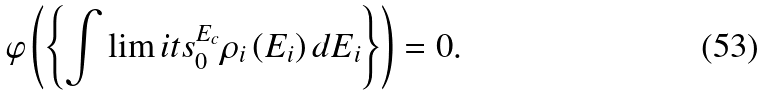Convert formula to latex. <formula><loc_0><loc_0><loc_500><loc_500>\varphi \left ( \left \{ \int \lim i t s _ { 0 } ^ { E _ { c } } \rho _ { i } \left ( E _ { i } \right ) d E _ { i } \right \} \right ) = 0 .</formula> 